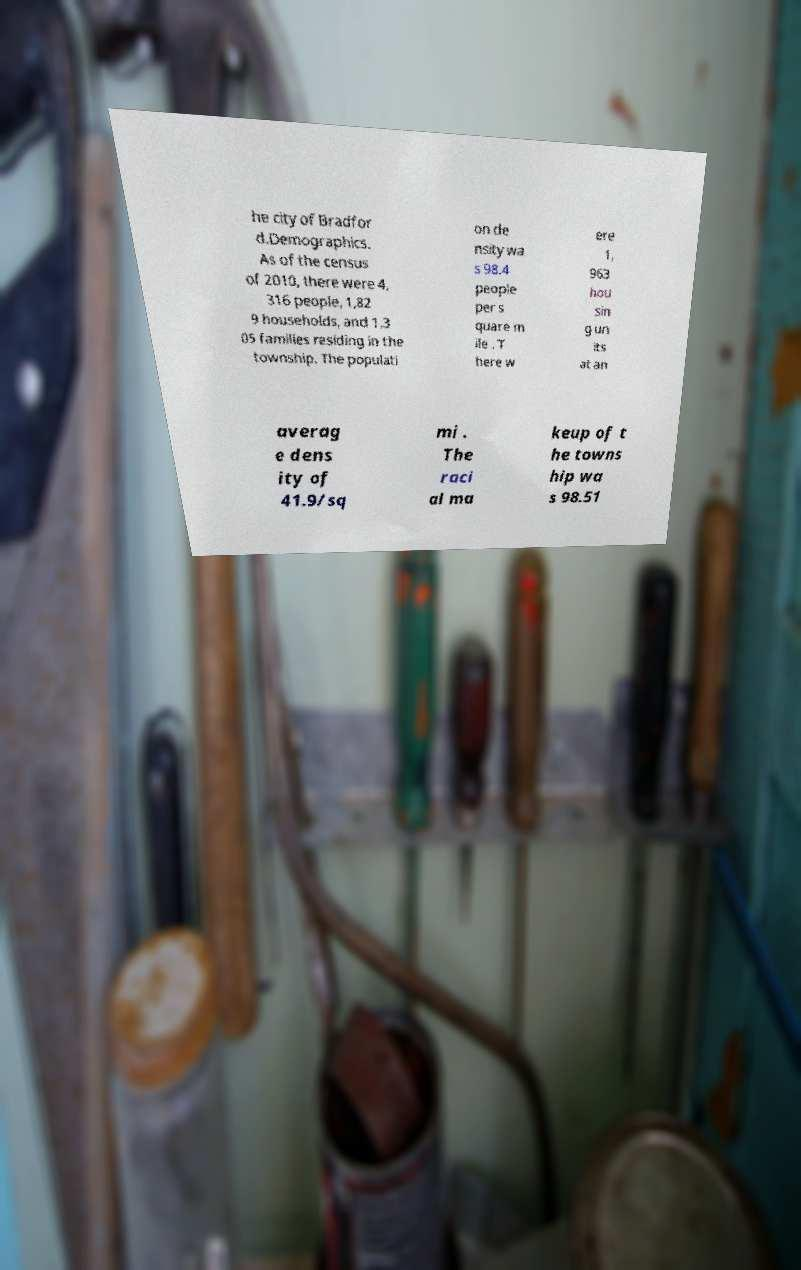Please identify and transcribe the text found in this image. he city of Bradfor d.Demographics. As of the census of 2010, there were 4, 316 people, 1,82 9 households, and 1,3 05 families residing in the township. The populati on de nsity wa s 98.4 people per s quare m ile . T here w ere 1, 963 hou sin g un its at an averag e dens ity of 41.9/sq mi . The raci al ma keup of t he towns hip wa s 98.51 